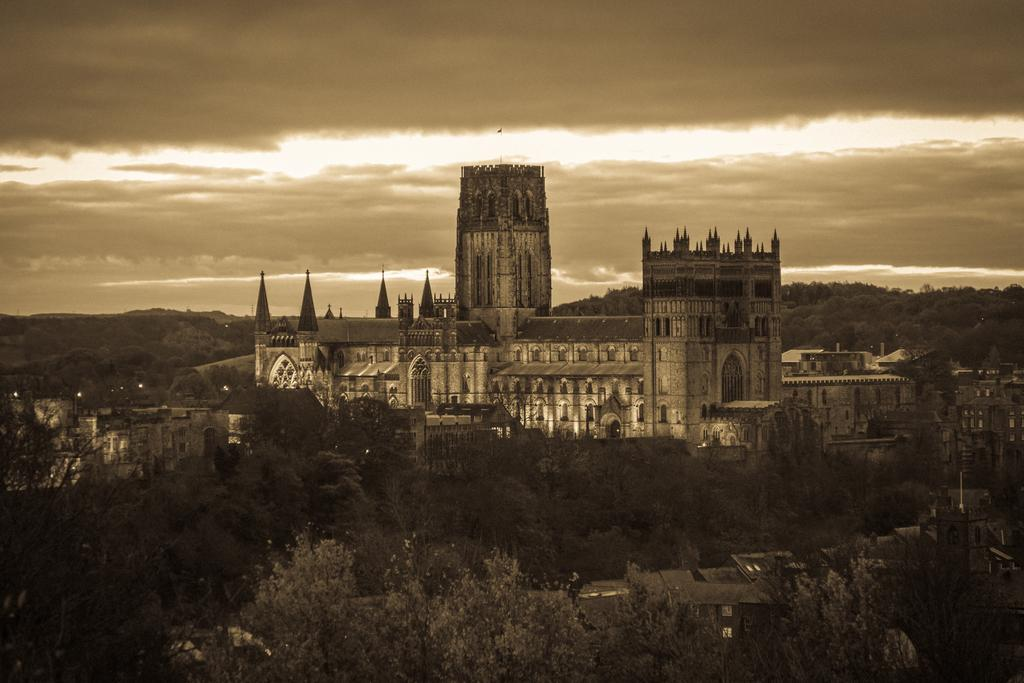What type of natural vegetation is present in the image? There are many trees in the image. What artificial light sources can be seen in the image? There are lights visible in the image. What type of man-made structure is visible in the background of the image? There is a building in the background of the image. What is the color of the sky in the image? The sky is gray in color. What type of advertisement can be seen on the trees in the image? There are no advertisements visible on the trees in the image; they are simply trees. How many crows are perched on the lights in the image? There are no crows present in the image; only trees, lights, and a building are visible. 